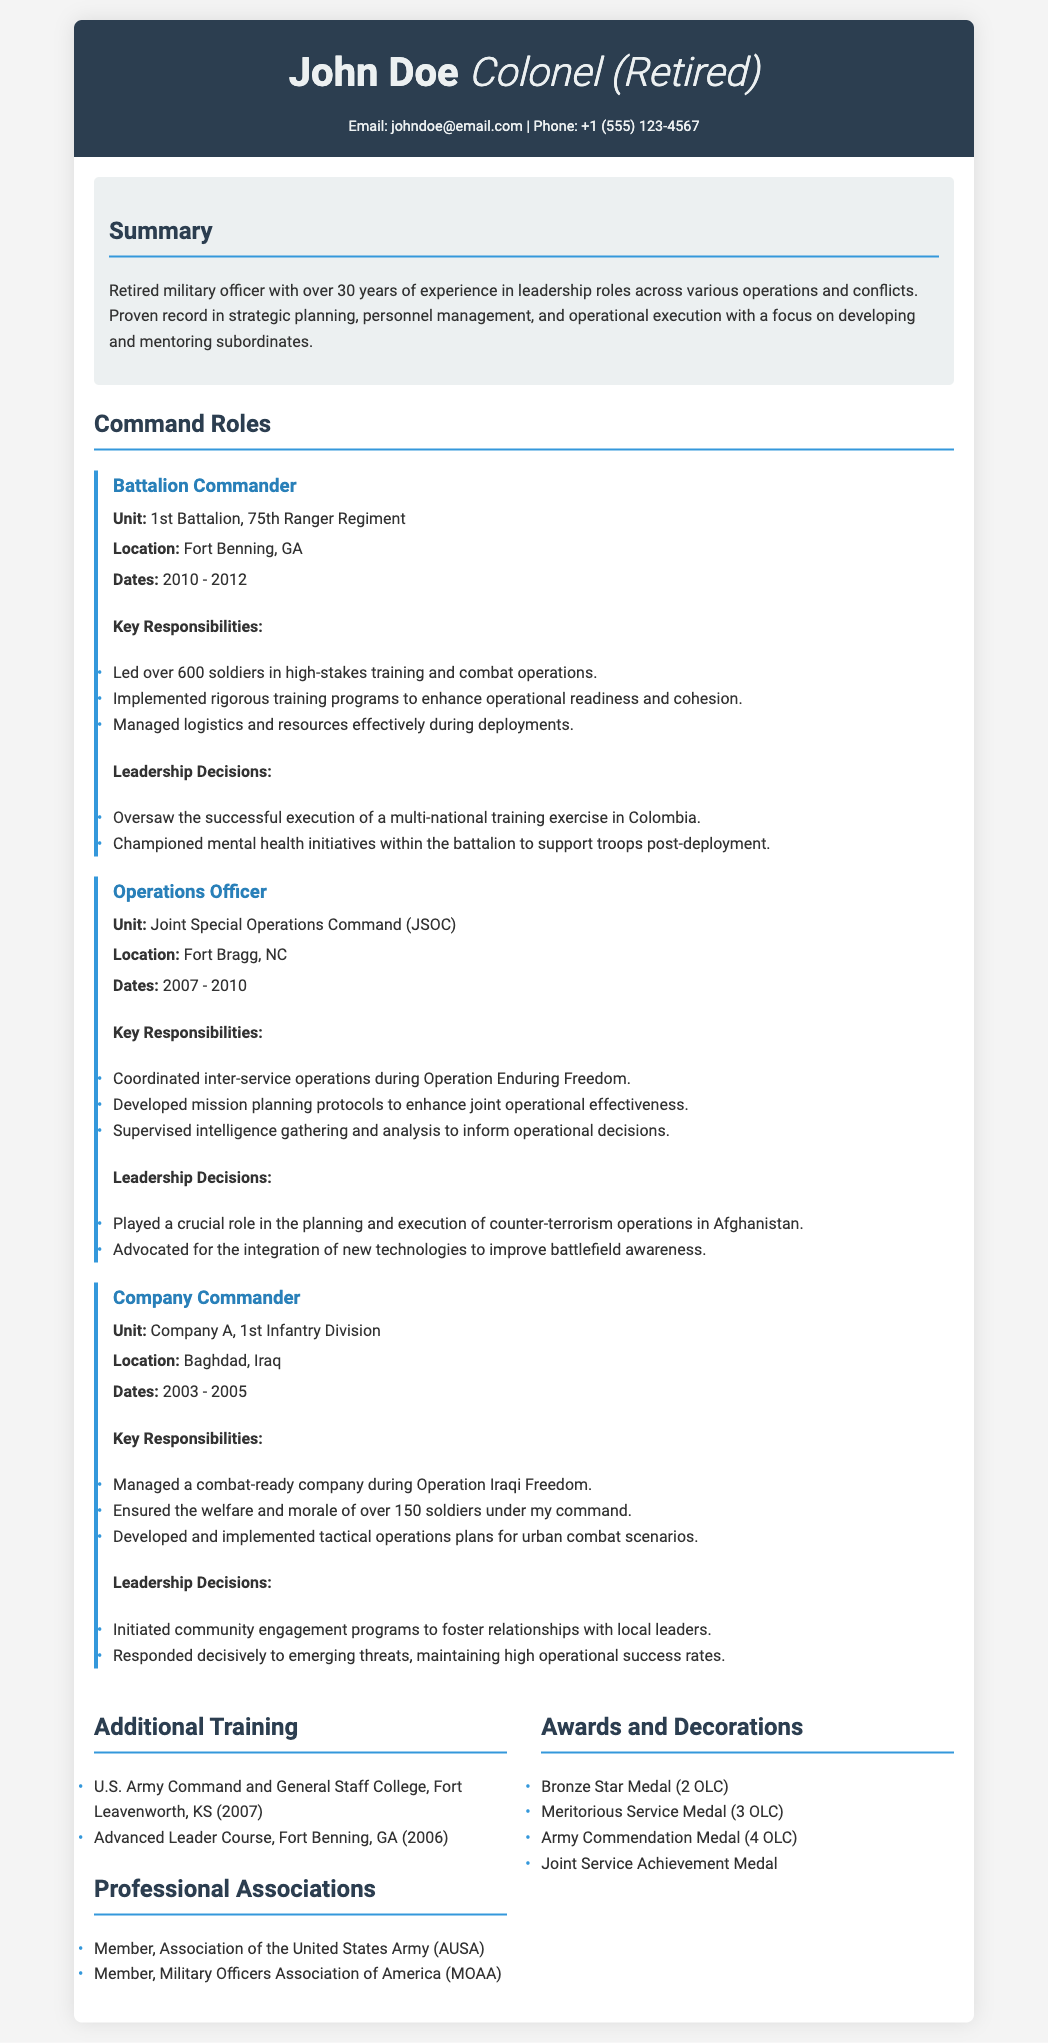What is the name of the retired officer? The resume states that the officer's name is John Doe.
Answer: John Doe What was John Doe's rank upon retirement? The rank held by the officer is indicated as Colonel (Retired).
Answer: Colonel (Retired) Which battalion did John Doe command? According to the document, he led the 1st Battalion, 75th Ranger Regiment.
Answer: 1st Battalion, 75th Ranger Regiment What years did John Doe serve as Operations Officer? The tenure for this role is specified as 2007 to 2010.
Answer: 2007 - 2010 List one of the leadership decisions made as Battalion Commander. A specific leadership decision noted is overseeing a successful execution of a multi-national training exercise in Colombia.
Answer: Multi-national training exercise in Colombia How many soldiers did John Doe manage as Company Commander? The document specifies that he managed over 150 soldiers.
Answer: Over 150 soldiers What training did John Doe complete in 2006? The document indicates he completed the Advanced Leader Course in 2006.
Answer: Advanced Leader Course How many Bronze Star Medals was John Doe awarded? The awards section states he received 2 Oak Leaf Clusters for the Bronze Star Medal.
Answer: 2 OLC Which professional association is John Doe a member of? The document mentions that he is a member of the Association of the United States Army.
Answer: Association of the United States Army 